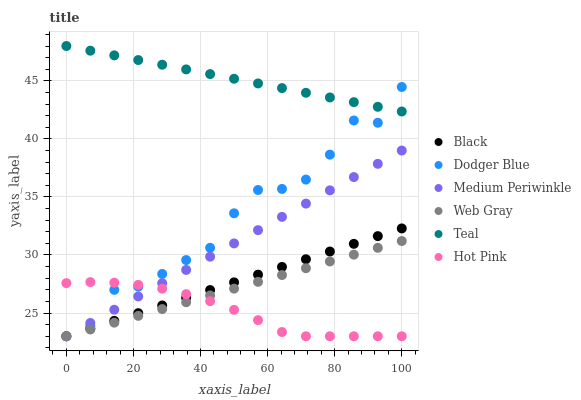Does Hot Pink have the minimum area under the curve?
Answer yes or no. Yes. Does Teal have the maximum area under the curve?
Answer yes or no. Yes. Does Medium Periwinkle have the minimum area under the curve?
Answer yes or no. No. Does Medium Periwinkle have the maximum area under the curve?
Answer yes or no. No. Is Teal the smoothest?
Answer yes or no. Yes. Is Dodger Blue the roughest?
Answer yes or no. Yes. Is Hot Pink the smoothest?
Answer yes or no. No. Is Hot Pink the roughest?
Answer yes or no. No. Does Web Gray have the lowest value?
Answer yes or no. Yes. Does Teal have the lowest value?
Answer yes or no. No. Does Teal have the highest value?
Answer yes or no. Yes. Does Medium Periwinkle have the highest value?
Answer yes or no. No. Is Black less than Teal?
Answer yes or no. Yes. Is Teal greater than Medium Periwinkle?
Answer yes or no. Yes. Does Black intersect Medium Periwinkle?
Answer yes or no. Yes. Is Black less than Medium Periwinkle?
Answer yes or no. No. Is Black greater than Medium Periwinkle?
Answer yes or no. No. Does Black intersect Teal?
Answer yes or no. No. 